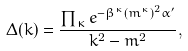Convert formula to latex. <formula><loc_0><loc_0><loc_500><loc_500>\Delta ( k ) = \frac { \prod _ { \kappa } e ^ { - \beta ^ { \kappa } ( m ^ { \kappa } ) ^ { 2 } \alpha ^ { \prime } } } { k ^ { 2 } - m ^ { 2 } } ,</formula> 